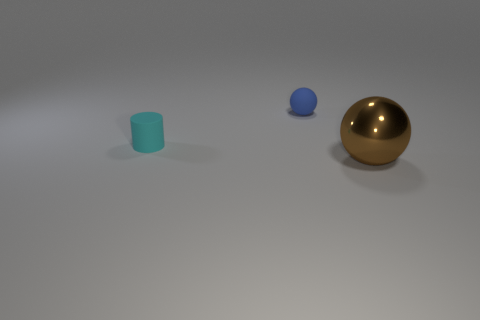Add 2 matte things. How many objects exist? 5 Subtract all cyan spheres. Subtract all green cubes. How many spheres are left? 2 Subtract all small purple cylinders. Subtract all blue matte objects. How many objects are left? 2 Add 1 large metallic spheres. How many large metallic spheres are left? 2 Add 3 tiny brown rubber cylinders. How many tiny brown rubber cylinders exist? 3 Subtract 0 brown blocks. How many objects are left? 3 Subtract all spheres. How many objects are left? 1 